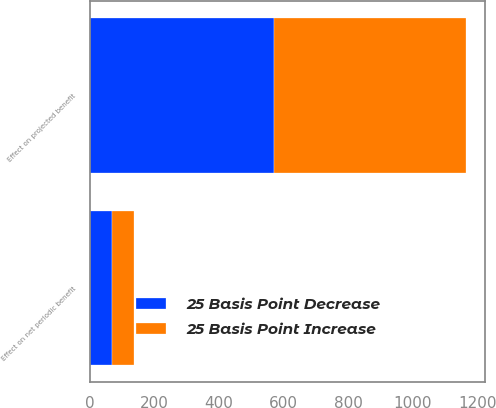Convert chart. <chart><loc_0><loc_0><loc_500><loc_500><stacked_bar_chart><ecel><fcel>Effect on net periodic benefit<fcel>Effect on projected benefit<nl><fcel>25 Basis Point Decrease<fcel>67<fcel>571<nl><fcel>25 Basis Point Increase<fcel>68<fcel>595<nl></chart> 